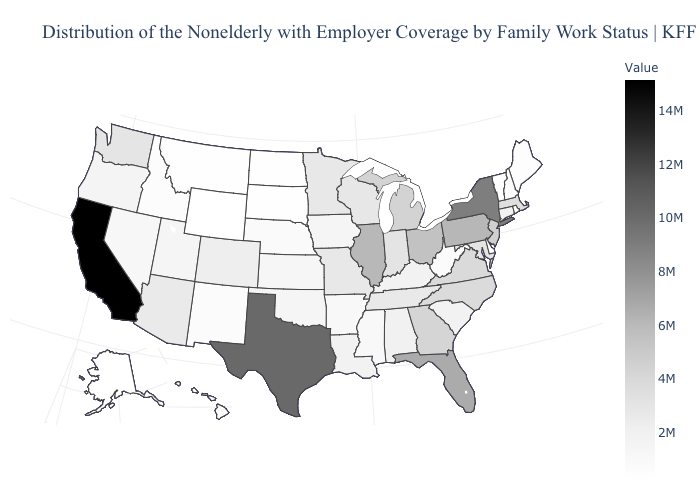Is the legend a continuous bar?
Quick response, please. Yes. Among the states that border Kansas , does Missouri have the lowest value?
Be succinct. No. Among the states that border Rhode Island , does Connecticut have the lowest value?
Concise answer only. Yes. Which states hav the highest value in the South?
Quick response, please. Texas. Does Arizona have a lower value than Texas?
Answer briefly. Yes. Does Massachusetts have a lower value than Pennsylvania?
Quick response, please. Yes. Does West Virginia have a higher value than New Jersey?
Quick response, please. No. Among the states that border Utah , does Arizona have the highest value?
Answer briefly. Yes. 